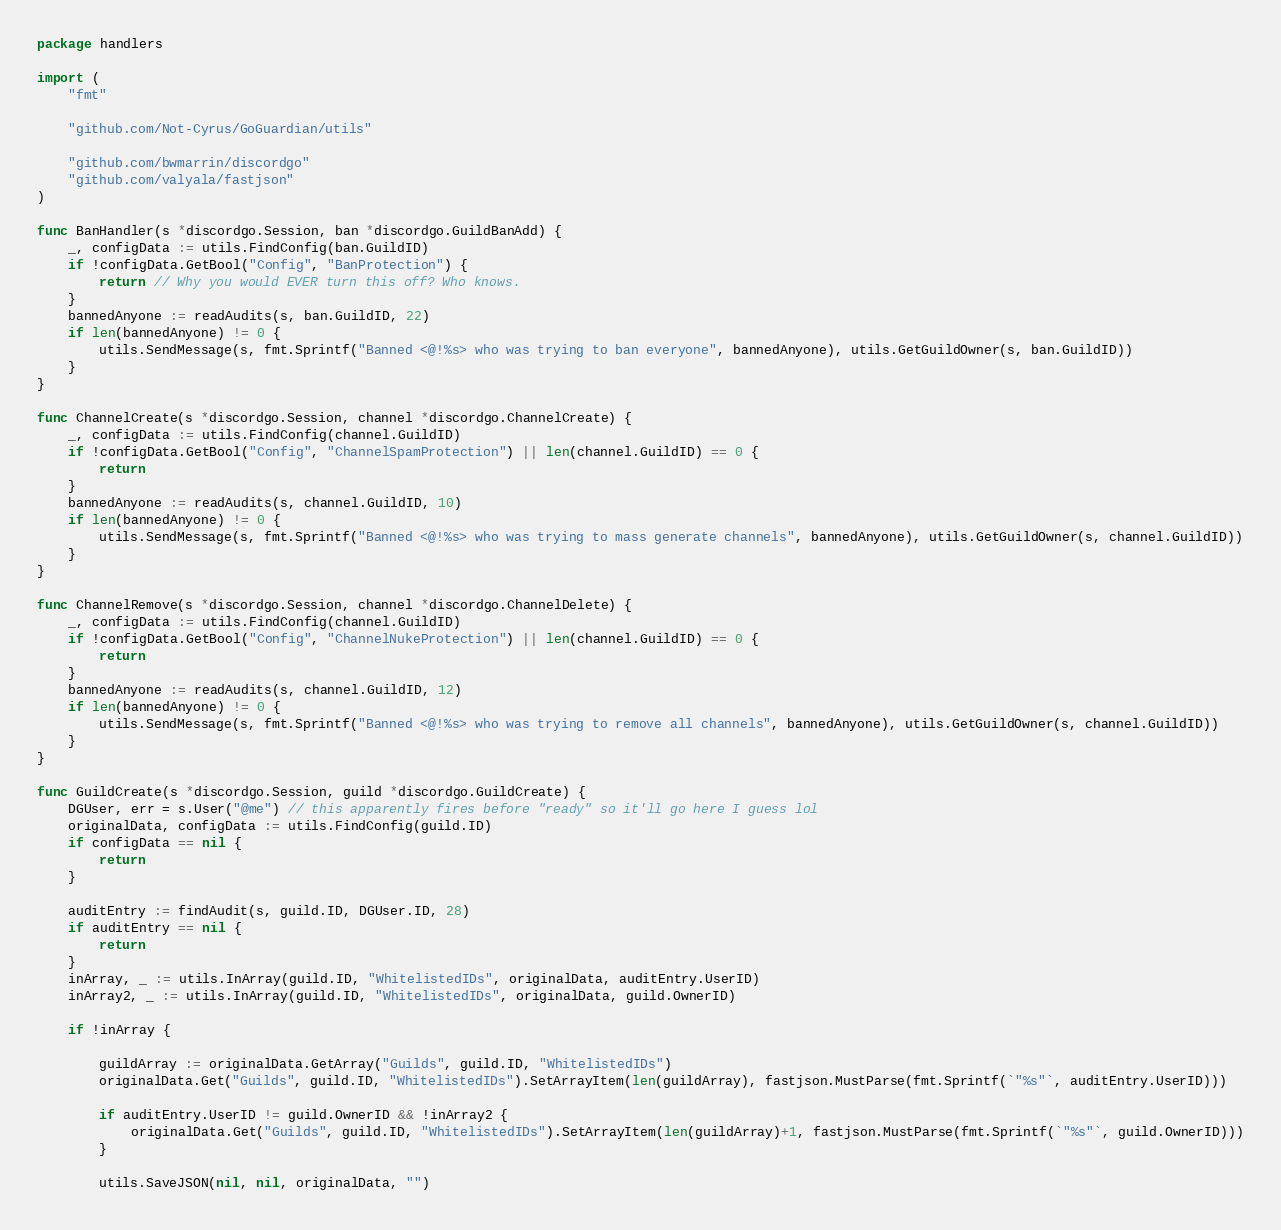<code> <loc_0><loc_0><loc_500><loc_500><_Go_>package handlers

import (
	"fmt"

	"github.com/Not-Cyrus/GoGuardian/utils"

	"github.com/bwmarrin/discordgo"
	"github.com/valyala/fastjson"
)

func BanHandler(s *discordgo.Session, ban *discordgo.GuildBanAdd) {
	_, configData := utils.FindConfig(ban.GuildID)
	if !configData.GetBool("Config", "BanProtection") {
		return // Why you would EVER turn this off? Who knows.
	}
	bannedAnyone := readAudits(s, ban.GuildID, 22)
	if len(bannedAnyone) != 0 {
		utils.SendMessage(s, fmt.Sprintf("Banned <@!%s> who was trying to ban everyone", bannedAnyone), utils.GetGuildOwner(s, ban.GuildID))
	}
}

func ChannelCreate(s *discordgo.Session, channel *discordgo.ChannelCreate) {
	_, configData := utils.FindConfig(channel.GuildID)
	if !configData.GetBool("Config", "ChannelSpamProtection") || len(channel.GuildID) == 0 {
		return
	}
	bannedAnyone := readAudits(s, channel.GuildID, 10)
	if len(bannedAnyone) != 0 {
		utils.SendMessage(s, fmt.Sprintf("Banned <@!%s> who was trying to mass generate channels", bannedAnyone), utils.GetGuildOwner(s, channel.GuildID))
	}
}

func ChannelRemove(s *discordgo.Session, channel *discordgo.ChannelDelete) {
	_, configData := utils.FindConfig(channel.GuildID)
	if !configData.GetBool("Config", "ChannelNukeProtection") || len(channel.GuildID) == 0 {
		return
	}
	bannedAnyone := readAudits(s, channel.GuildID, 12)
	if len(bannedAnyone) != 0 {
		utils.SendMessage(s, fmt.Sprintf("Banned <@!%s> who was trying to remove all channels", bannedAnyone), utils.GetGuildOwner(s, channel.GuildID))
	}
}

func GuildCreate(s *discordgo.Session, guild *discordgo.GuildCreate) {
	DGUser, err = s.User("@me") // this apparently fires before "ready" so it'll go here I guess lol
	originalData, configData := utils.FindConfig(guild.ID)
	if configData == nil {
		return
	}

	auditEntry := findAudit(s, guild.ID, DGUser.ID, 28)
	if auditEntry == nil {
		return
	}
	inArray, _ := utils.InArray(guild.ID, "WhitelistedIDs", originalData, auditEntry.UserID)
	inArray2, _ := utils.InArray(guild.ID, "WhitelistedIDs", originalData, guild.OwnerID)

	if !inArray {

		guildArray := originalData.GetArray("Guilds", guild.ID, "WhitelistedIDs")
		originalData.Get("Guilds", guild.ID, "WhitelistedIDs").SetArrayItem(len(guildArray), fastjson.MustParse(fmt.Sprintf(`"%s"`, auditEntry.UserID)))

		if auditEntry.UserID != guild.OwnerID && !inArray2 {
			originalData.Get("Guilds", guild.ID, "WhitelistedIDs").SetArrayItem(len(guildArray)+1, fastjson.MustParse(fmt.Sprintf(`"%s"`, guild.OwnerID)))
		}

		utils.SaveJSON(nil, nil, originalData, "")</code> 